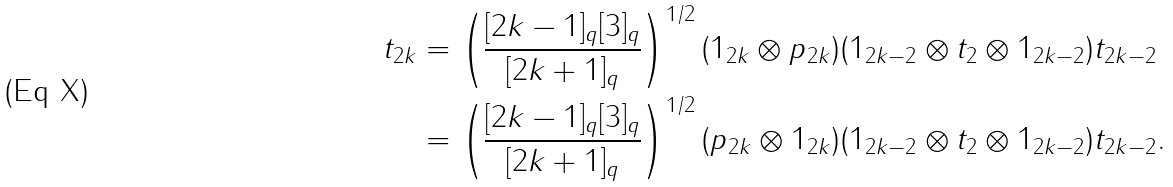Convert formula to latex. <formula><loc_0><loc_0><loc_500><loc_500>t _ { 2 k } & = \left ( \frac { [ 2 k - 1 ] _ { q } [ 3 ] _ { q } } { [ 2 k + 1 ] _ { q } } \right ) ^ { 1 / 2 } ( 1 _ { 2 k } \otimes p _ { 2 k } ) ( 1 _ { 2 k - 2 } \otimes t _ { 2 } \otimes 1 _ { 2 k - 2 } ) t _ { 2 k - 2 } \\ & = \left ( \frac { [ 2 k - 1 ] _ { q } [ 3 ] _ { q } } { [ 2 k + 1 ] _ { q } } \right ) ^ { 1 / 2 } ( p _ { 2 k } \otimes 1 _ { 2 k } ) ( 1 _ { 2 k - 2 } \otimes t _ { 2 } \otimes 1 _ { 2 k - 2 } ) t _ { 2 k - 2 } .</formula> 